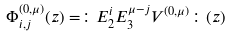Convert formula to latex. <formula><loc_0><loc_0><loc_500><loc_500>\Phi _ { i , j } ^ { ( 0 , \mu ) } ( z ) = \colon E _ { 2 } ^ { i } E _ { 3 } ^ { \mu - j } V ^ { ( 0 , \mu ) } \colon ( z )</formula> 